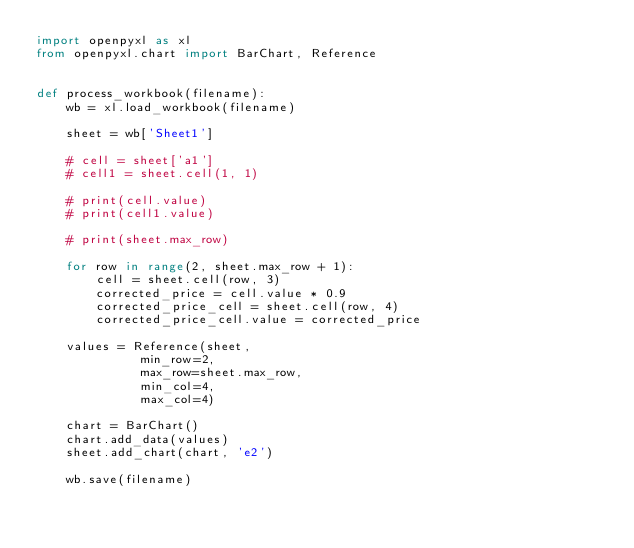<code> <loc_0><loc_0><loc_500><loc_500><_Python_>import openpyxl as xl
from openpyxl.chart import BarChart, Reference


def process_workbook(filename):
    wb = xl.load_workbook(filename)

    sheet = wb['Sheet1']

    # cell = sheet['a1']
    # cell1 = sheet.cell(1, 1)

    # print(cell.value)
    # print(cell1.value)

    # print(sheet.max_row)

    for row in range(2, sheet.max_row + 1):
        cell = sheet.cell(row, 3)
        corrected_price = cell.value * 0.9
        corrected_price_cell = sheet.cell(row, 4)
        corrected_price_cell.value = corrected_price

    values = Reference(sheet,
              min_row=2,
              max_row=sheet.max_row,
              min_col=4,
              max_col=4)

    chart = BarChart()
    chart.add_data(values)
    sheet.add_chart(chart, 'e2')

    wb.save(filename)</code> 